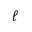<formula> <loc_0><loc_0><loc_500><loc_500>\ell</formula> 